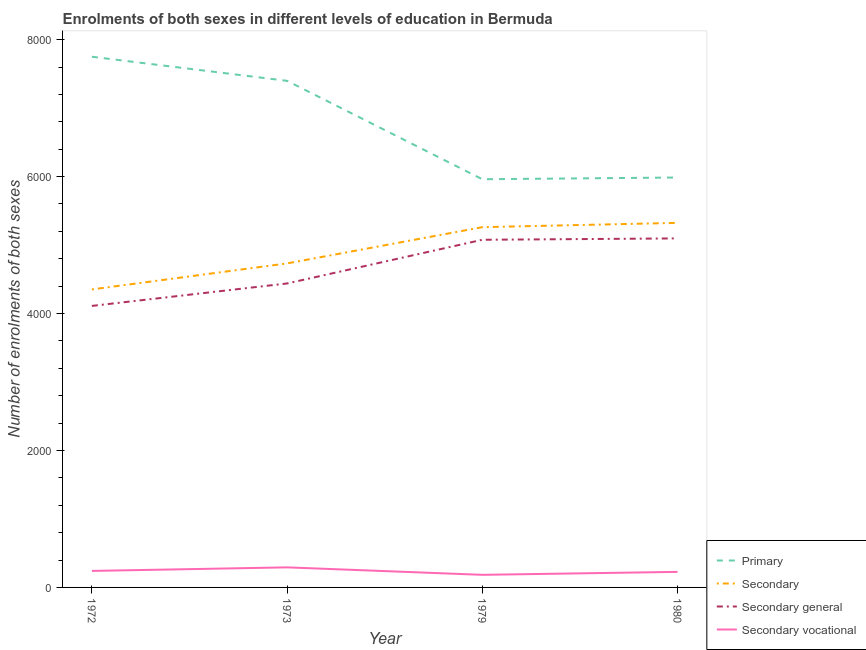Is the number of lines equal to the number of legend labels?
Offer a very short reply. Yes. What is the number of enrolments in primary education in 1979?
Offer a very short reply. 5961. Across all years, what is the maximum number of enrolments in secondary vocational education?
Offer a terse response. 293. Across all years, what is the minimum number of enrolments in primary education?
Give a very brief answer. 5961. What is the total number of enrolments in secondary vocational education in the graph?
Give a very brief answer. 945. What is the difference between the number of enrolments in secondary general education in 1973 and that in 1980?
Your answer should be compact. -658. What is the difference between the number of enrolments in secondary vocational education in 1979 and the number of enrolments in primary education in 1973?
Offer a very short reply. -7214. What is the average number of enrolments in secondary general education per year?
Keep it short and to the point. 4681. In the year 1972, what is the difference between the number of enrolments in primary education and number of enrolments in secondary general education?
Ensure brevity in your answer.  3639. In how many years, is the number of enrolments in secondary vocational education greater than 5600?
Offer a very short reply. 0. What is the ratio of the number of enrolments in secondary vocational education in 1979 to that in 1980?
Your answer should be very brief. 0.81. Is the difference between the number of enrolments in secondary vocational education in 1973 and 1979 greater than the difference between the number of enrolments in secondary education in 1973 and 1979?
Your answer should be compact. Yes. What is the difference between the highest and the second highest number of enrolments in secondary education?
Offer a very short reply. 63. What is the difference between the highest and the lowest number of enrolments in secondary vocational education?
Provide a short and direct response. 109. Is it the case that in every year, the sum of the number of enrolments in primary education and number of enrolments in secondary education is greater than the sum of number of enrolments in secondary vocational education and number of enrolments in secondary general education?
Give a very brief answer. Yes. How many years are there in the graph?
Ensure brevity in your answer.  4. What is the difference between two consecutive major ticks on the Y-axis?
Your response must be concise. 2000. Does the graph contain any zero values?
Keep it short and to the point. No. How many legend labels are there?
Make the answer very short. 4. What is the title of the graph?
Your response must be concise. Enrolments of both sexes in different levels of education in Bermuda. Does "Social Protection" appear as one of the legend labels in the graph?
Offer a terse response. No. What is the label or title of the Y-axis?
Offer a very short reply. Number of enrolments of both sexes. What is the Number of enrolments of both sexes of Primary in 1972?
Provide a short and direct response. 7750. What is the Number of enrolments of both sexes in Secondary in 1972?
Offer a very short reply. 4352. What is the Number of enrolments of both sexes in Secondary general in 1972?
Keep it short and to the point. 4111. What is the Number of enrolments of both sexes in Secondary vocational in 1972?
Give a very brief answer. 241. What is the Number of enrolments of both sexes of Primary in 1973?
Provide a short and direct response. 7398. What is the Number of enrolments of both sexes of Secondary in 1973?
Give a very brief answer. 4732. What is the Number of enrolments of both sexes of Secondary general in 1973?
Provide a succinct answer. 4439. What is the Number of enrolments of both sexes in Secondary vocational in 1973?
Your answer should be compact. 293. What is the Number of enrolments of both sexes in Primary in 1979?
Your answer should be very brief. 5961. What is the Number of enrolments of both sexes in Secondary in 1979?
Provide a succinct answer. 5261. What is the Number of enrolments of both sexes in Secondary general in 1979?
Ensure brevity in your answer.  5077. What is the Number of enrolments of both sexes of Secondary vocational in 1979?
Keep it short and to the point. 184. What is the Number of enrolments of both sexes of Primary in 1980?
Ensure brevity in your answer.  5986. What is the Number of enrolments of both sexes of Secondary in 1980?
Offer a very short reply. 5324. What is the Number of enrolments of both sexes of Secondary general in 1980?
Offer a very short reply. 5097. What is the Number of enrolments of both sexes in Secondary vocational in 1980?
Offer a very short reply. 227. Across all years, what is the maximum Number of enrolments of both sexes in Primary?
Your answer should be compact. 7750. Across all years, what is the maximum Number of enrolments of both sexes in Secondary?
Keep it short and to the point. 5324. Across all years, what is the maximum Number of enrolments of both sexes of Secondary general?
Make the answer very short. 5097. Across all years, what is the maximum Number of enrolments of both sexes in Secondary vocational?
Give a very brief answer. 293. Across all years, what is the minimum Number of enrolments of both sexes of Primary?
Your answer should be very brief. 5961. Across all years, what is the minimum Number of enrolments of both sexes in Secondary?
Offer a very short reply. 4352. Across all years, what is the minimum Number of enrolments of both sexes of Secondary general?
Provide a succinct answer. 4111. Across all years, what is the minimum Number of enrolments of both sexes of Secondary vocational?
Offer a very short reply. 184. What is the total Number of enrolments of both sexes in Primary in the graph?
Keep it short and to the point. 2.71e+04. What is the total Number of enrolments of both sexes of Secondary in the graph?
Keep it short and to the point. 1.97e+04. What is the total Number of enrolments of both sexes of Secondary general in the graph?
Your response must be concise. 1.87e+04. What is the total Number of enrolments of both sexes of Secondary vocational in the graph?
Keep it short and to the point. 945. What is the difference between the Number of enrolments of both sexes in Primary in 1972 and that in 1973?
Give a very brief answer. 352. What is the difference between the Number of enrolments of both sexes in Secondary in 1972 and that in 1973?
Offer a terse response. -380. What is the difference between the Number of enrolments of both sexes in Secondary general in 1972 and that in 1973?
Ensure brevity in your answer.  -328. What is the difference between the Number of enrolments of both sexes of Secondary vocational in 1972 and that in 1973?
Your answer should be very brief. -52. What is the difference between the Number of enrolments of both sexes in Primary in 1972 and that in 1979?
Your answer should be very brief. 1789. What is the difference between the Number of enrolments of both sexes of Secondary in 1972 and that in 1979?
Offer a very short reply. -909. What is the difference between the Number of enrolments of both sexes of Secondary general in 1972 and that in 1979?
Make the answer very short. -966. What is the difference between the Number of enrolments of both sexes in Primary in 1972 and that in 1980?
Your answer should be compact. 1764. What is the difference between the Number of enrolments of both sexes of Secondary in 1972 and that in 1980?
Make the answer very short. -972. What is the difference between the Number of enrolments of both sexes of Secondary general in 1972 and that in 1980?
Make the answer very short. -986. What is the difference between the Number of enrolments of both sexes in Secondary vocational in 1972 and that in 1980?
Offer a terse response. 14. What is the difference between the Number of enrolments of both sexes of Primary in 1973 and that in 1979?
Your answer should be compact. 1437. What is the difference between the Number of enrolments of both sexes of Secondary in 1973 and that in 1979?
Provide a succinct answer. -529. What is the difference between the Number of enrolments of both sexes in Secondary general in 1973 and that in 1979?
Your response must be concise. -638. What is the difference between the Number of enrolments of both sexes of Secondary vocational in 1973 and that in 1979?
Offer a terse response. 109. What is the difference between the Number of enrolments of both sexes in Primary in 1973 and that in 1980?
Make the answer very short. 1412. What is the difference between the Number of enrolments of both sexes of Secondary in 1973 and that in 1980?
Your response must be concise. -592. What is the difference between the Number of enrolments of both sexes of Secondary general in 1973 and that in 1980?
Give a very brief answer. -658. What is the difference between the Number of enrolments of both sexes of Secondary vocational in 1973 and that in 1980?
Your response must be concise. 66. What is the difference between the Number of enrolments of both sexes in Primary in 1979 and that in 1980?
Your answer should be compact. -25. What is the difference between the Number of enrolments of both sexes in Secondary in 1979 and that in 1980?
Offer a terse response. -63. What is the difference between the Number of enrolments of both sexes in Secondary general in 1979 and that in 1980?
Provide a succinct answer. -20. What is the difference between the Number of enrolments of both sexes of Secondary vocational in 1979 and that in 1980?
Give a very brief answer. -43. What is the difference between the Number of enrolments of both sexes in Primary in 1972 and the Number of enrolments of both sexes in Secondary in 1973?
Provide a short and direct response. 3018. What is the difference between the Number of enrolments of both sexes in Primary in 1972 and the Number of enrolments of both sexes in Secondary general in 1973?
Your answer should be very brief. 3311. What is the difference between the Number of enrolments of both sexes of Primary in 1972 and the Number of enrolments of both sexes of Secondary vocational in 1973?
Give a very brief answer. 7457. What is the difference between the Number of enrolments of both sexes in Secondary in 1972 and the Number of enrolments of both sexes in Secondary general in 1973?
Offer a terse response. -87. What is the difference between the Number of enrolments of both sexes of Secondary in 1972 and the Number of enrolments of both sexes of Secondary vocational in 1973?
Make the answer very short. 4059. What is the difference between the Number of enrolments of both sexes in Secondary general in 1972 and the Number of enrolments of both sexes in Secondary vocational in 1973?
Provide a succinct answer. 3818. What is the difference between the Number of enrolments of both sexes in Primary in 1972 and the Number of enrolments of both sexes in Secondary in 1979?
Give a very brief answer. 2489. What is the difference between the Number of enrolments of both sexes of Primary in 1972 and the Number of enrolments of both sexes of Secondary general in 1979?
Your answer should be compact. 2673. What is the difference between the Number of enrolments of both sexes in Primary in 1972 and the Number of enrolments of both sexes in Secondary vocational in 1979?
Make the answer very short. 7566. What is the difference between the Number of enrolments of both sexes in Secondary in 1972 and the Number of enrolments of both sexes in Secondary general in 1979?
Make the answer very short. -725. What is the difference between the Number of enrolments of both sexes in Secondary in 1972 and the Number of enrolments of both sexes in Secondary vocational in 1979?
Provide a short and direct response. 4168. What is the difference between the Number of enrolments of both sexes of Secondary general in 1972 and the Number of enrolments of both sexes of Secondary vocational in 1979?
Provide a succinct answer. 3927. What is the difference between the Number of enrolments of both sexes of Primary in 1972 and the Number of enrolments of both sexes of Secondary in 1980?
Make the answer very short. 2426. What is the difference between the Number of enrolments of both sexes of Primary in 1972 and the Number of enrolments of both sexes of Secondary general in 1980?
Offer a very short reply. 2653. What is the difference between the Number of enrolments of both sexes of Primary in 1972 and the Number of enrolments of both sexes of Secondary vocational in 1980?
Your answer should be compact. 7523. What is the difference between the Number of enrolments of both sexes of Secondary in 1972 and the Number of enrolments of both sexes of Secondary general in 1980?
Your answer should be compact. -745. What is the difference between the Number of enrolments of both sexes in Secondary in 1972 and the Number of enrolments of both sexes in Secondary vocational in 1980?
Provide a succinct answer. 4125. What is the difference between the Number of enrolments of both sexes of Secondary general in 1972 and the Number of enrolments of both sexes of Secondary vocational in 1980?
Give a very brief answer. 3884. What is the difference between the Number of enrolments of both sexes in Primary in 1973 and the Number of enrolments of both sexes in Secondary in 1979?
Your response must be concise. 2137. What is the difference between the Number of enrolments of both sexes of Primary in 1973 and the Number of enrolments of both sexes of Secondary general in 1979?
Offer a terse response. 2321. What is the difference between the Number of enrolments of both sexes in Primary in 1973 and the Number of enrolments of both sexes in Secondary vocational in 1979?
Your answer should be very brief. 7214. What is the difference between the Number of enrolments of both sexes of Secondary in 1973 and the Number of enrolments of both sexes of Secondary general in 1979?
Keep it short and to the point. -345. What is the difference between the Number of enrolments of both sexes in Secondary in 1973 and the Number of enrolments of both sexes in Secondary vocational in 1979?
Give a very brief answer. 4548. What is the difference between the Number of enrolments of both sexes in Secondary general in 1973 and the Number of enrolments of both sexes in Secondary vocational in 1979?
Your response must be concise. 4255. What is the difference between the Number of enrolments of both sexes of Primary in 1973 and the Number of enrolments of both sexes of Secondary in 1980?
Ensure brevity in your answer.  2074. What is the difference between the Number of enrolments of both sexes in Primary in 1973 and the Number of enrolments of both sexes in Secondary general in 1980?
Ensure brevity in your answer.  2301. What is the difference between the Number of enrolments of both sexes in Primary in 1973 and the Number of enrolments of both sexes in Secondary vocational in 1980?
Offer a terse response. 7171. What is the difference between the Number of enrolments of both sexes in Secondary in 1973 and the Number of enrolments of both sexes in Secondary general in 1980?
Your answer should be very brief. -365. What is the difference between the Number of enrolments of both sexes of Secondary in 1973 and the Number of enrolments of both sexes of Secondary vocational in 1980?
Give a very brief answer. 4505. What is the difference between the Number of enrolments of both sexes in Secondary general in 1973 and the Number of enrolments of both sexes in Secondary vocational in 1980?
Give a very brief answer. 4212. What is the difference between the Number of enrolments of both sexes of Primary in 1979 and the Number of enrolments of both sexes of Secondary in 1980?
Provide a short and direct response. 637. What is the difference between the Number of enrolments of both sexes of Primary in 1979 and the Number of enrolments of both sexes of Secondary general in 1980?
Provide a succinct answer. 864. What is the difference between the Number of enrolments of both sexes of Primary in 1979 and the Number of enrolments of both sexes of Secondary vocational in 1980?
Provide a short and direct response. 5734. What is the difference between the Number of enrolments of both sexes in Secondary in 1979 and the Number of enrolments of both sexes in Secondary general in 1980?
Make the answer very short. 164. What is the difference between the Number of enrolments of both sexes of Secondary in 1979 and the Number of enrolments of both sexes of Secondary vocational in 1980?
Offer a terse response. 5034. What is the difference between the Number of enrolments of both sexes of Secondary general in 1979 and the Number of enrolments of both sexes of Secondary vocational in 1980?
Make the answer very short. 4850. What is the average Number of enrolments of both sexes in Primary per year?
Provide a short and direct response. 6773.75. What is the average Number of enrolments of both sexes in Secondary per year?
Provide a succinct answer. 4917.25. What is the average Number of enrolments of both sexes in Secondary general per year?
Your answer should be compact. 4681. What is the average Number of enrolments of both sexes of Secondary vocational per year?
Your response must be concise. 236.25. In the year 1972, what is the difference between the Number of enrolments of both sexes in Primary and Number of enrolments of both sexes in Secondary?
Make the answer very short. 3398. In the year 1972, what is the difference between the Number of enrolments of both sexes of Primary and Number of enrolments of both sexes of Secondary general?
Give a very brief answer. 3639. In the year 1972, what is the difference between the Number of enrolments of both sexes in Primary and Number of enrolments of both sexes in Secondary vocational?
Ensure brevity in your answer.  7509. In the year 1972, what is the difference between the Number of enrolments of both sexes of Secondary and Number of enrolments of both sexes of Secondary general?
Give a very brief answer. 241. In the year 1972, what is the difference between the Number of enrolments of both sexes in Secondary and Number of enrolments of both sexes in Secondary vocational?
Keep it short and to the point. 4111. In the year 1972, what is the difference between the Number of enrolments of both sexes in Secondary general and Number of enrolments of both sexes in Secondary vocational?
Provide a short and direct response. 3870. In the year 1973, what is the difference between the Number of enrolments of both sexes in Primary and Number of enrolments of both sexes in Secondary?
Your answer should be very brief. 2666. In the year 1973, what is the difference between the Number of enrolments of both sexes of Primary and Number of enrolments of both sexes of Secondary general?
Offer a terse response. 2959. In the year 1973, what is the difference between the Number of enrolments of both sexes in Primary and Number of enrolments of both sexes in Secondary vocational?
Your answer should be compact. 7105. In the year 1973, what is the difference between the Number of enrolments of both sexes in Secondary and Number of enrolments of both sexes in Secondary general?
Provide a short and direct response. 293. In the year 1973, what is the difference between the Number of enrolments of both sexes in Secondary and Number of enrolments of both sexes in Secondary vocational?
Give a very brief answer. 4439. In the year 1973, what is the difference between the Number of enrolments of both sexes in Secondary general and Number of enrolments of both sexes in Secondary vocational?
Keep it short and to the point. 4146. In the year 1979, what is the difference between the Number of enrolments of both sexes of Primary and Number of enrolments of both sexes of Secondary?
Provide a short and direct response. 700. In the year 1979, what is the difference between the Number of enrolments of both sexes in Primary and Number of enrolments of both sexes in Secondary general?
Your response must be concise. 884. In the year 1979, what is the difference between the Number of enrolments of both sexes of Primary and Number of enrolments of both sexes of Secondary vocational?
Give a very brief answer. 5777. In the year 1979, what is the difference between the Number of enrolments of both sexes of Secondary and Number of enrolments of both sexes of Secondary general?
Make the answer very short. 184. In the year 1979, what is the difference between the Number of enrolments of both sexes in Secondary and Number of enrolments of both sexes in Secondary vocational?
Provide a short and direct response. 5077. In the year 1979, what is the difference between the Number of enrolments of both sexes in Secondary general and Number of enrolments of both sexes in Secondary vocational?
Offer a very short reply. 4893. In the year 1980, what is the difference between the Number of enrolments of both sexes of Primary and Number of enrolments of both sexes of Secondary?
Your answer should be compact. 662. In the year 1980, what is the difference between the Number of enrolments of both sexes in Primary and Number of enrolments of both sexes in Secondary general?
Your answer should be compact. 889. In the year 1980, what is the difference between the Number of enrolments of both sexes of Primary and Number of enrolments of both sexes of Secondary vocational?
Your response must be concise. 5759. In the year 1980, what is the difference between the Number of enrolments of both sexes of Secondary and Number of enrolments of both sexes of Secondary general?
Make the answer very short. 227. In the year 1980, what is the difference between the Number of enrolments of both sexes of Secondary and Number of enrolments of both sexes of Secondary vocational?
Offer a very short reply. 5097. In the year 1980, what is the difference between the Number of enrolments of both sexes in Secondary general and Number of enrolments of both sexes in Secondary vocational?
Your answer should be very brief. 4870. What is the ratio of the Number of enrolments of both sexes in Primary in 1972 to that in 1973?
Offer a very short reply. 1.05. What is the ratio of the Number of enrolments of both sexes of Secondary in 1972 to that in 1973?
Your answer should be very brief. 0.92. What is the ratio of the Number of enrolments of both sexes in Secondary general in 1972 to that in 1973?
Provide a succinct answer. 0.93. What is the ratio of the Number of enrolments of both sexes in Secondary vocational in 1972 to that in 1973?
Provide a succinct answer. 0.82. What is the ratio of the Number of enrolments of both sexes of Primary in 1972 to that in 1979?
Provide a succinct answer. 1.3. What is the ratio of the Number of enrolments of both sexes of Secondary in 1972 to that in 1979?
Make the answer very short. 0.83. What is the ratio of the Number of enrolments of both sexes in Secondary general in 1972 to that in 1979?
Give a very brief answer. 0.81. What is the ratio of the Number of enrolments of both sexes in Secondary vocational in 1972 to that in 1979?
Provide a short and direct response. 1.31. What is the ratio of the Number of enrolments of both sexes of Primary in 1972 to that in 1980?
Ensure brevity in your answer.  1.29. What is the ratio of the Number of enrolments of both sexes of Secondary in 1972 to that in 1980?
Give a very brief answer. 0.82. What is the ratio of the Number of enrolments of both sexes in Secondary general in 1972 to that in 1980?
Give a very brief answer. 0.81. What is the ratio of the Number of enrolments of both sexes of Secondary vocational in 1972 to that in 1980?
Your answer should be very brief. 1.06. What is the ratio of the Number of enrolments of both sexes in Primary in 1973 to that in 1979?
Give a very brief answer. 1.24. What is the ratio of the Number of enrolments of both sexes in Secondary in 1973 to that in 1979?
Provide a succinct answer. 0.9. What is the ratio of the Number of enrolments of both sexes of Secondary general in 1973 to that in 1979?
Offer a very short reply. 0.87. What is the ratio of the Number of enrolments of both sexes of Secondary vocational in 1973 to that in 1979?
Offer a very short reply. 1.59. What is the ratio of the Number of enrolments of both sexes in Primary in 1973 to that in 1980?
Make the answer very short. 1.24. What is the ratio of the Number of enrolments of both sexes of Secondary in 1973 to that in 1980?
Make the answer very short. 0.89. What is the ratio of the Number of enrolments of both sexes in Secondary general in 1973 to that in 1980?
Offer a terse response. 0.87. What is the ratio of the Number of enrolments of both sexes of Secondary vocational in 1973 to that in 1980?
Provide a succinct answer. 1.29. What is the ratio of the Number of enrolments of both sexes of Secondary vocational in 1979 to that in 1980?
Your answer should be compact. 0.81. What is the difference between the highest and the second highest Number of enrolments of both sexes in Primary?
Offer a terse response. 352. What is the difference between the highest and the second highest Number of enrolments of both sexes of Secondary?
Your response must be concise. 63. What is the difference between the highest and the second highest Number of enrolments of both sexes of Secondary general?
Your answer should be very brief. 20. What is the difference between the highest and the second highest Number of enrolments of both sexes of Secondary vocational?
Offer a very short reply. 52. What is the difference between the highest and the lowest Number of enrolments of both sexes in Primary?
Offer a very short reply. 1789. What is the difference between the highest and the lowest Number of enrolments of both sexes in Secondary?
Your response must be concise. 972. What is the difference between the highest and the lowest Number of enrolments of both sexes of Secondary general?
Offer a very short reply. 986. What is the difference between the highest and the lowest Number of enrolments of both sexes of Secondary vocational?
Your response must be concise. 109. 